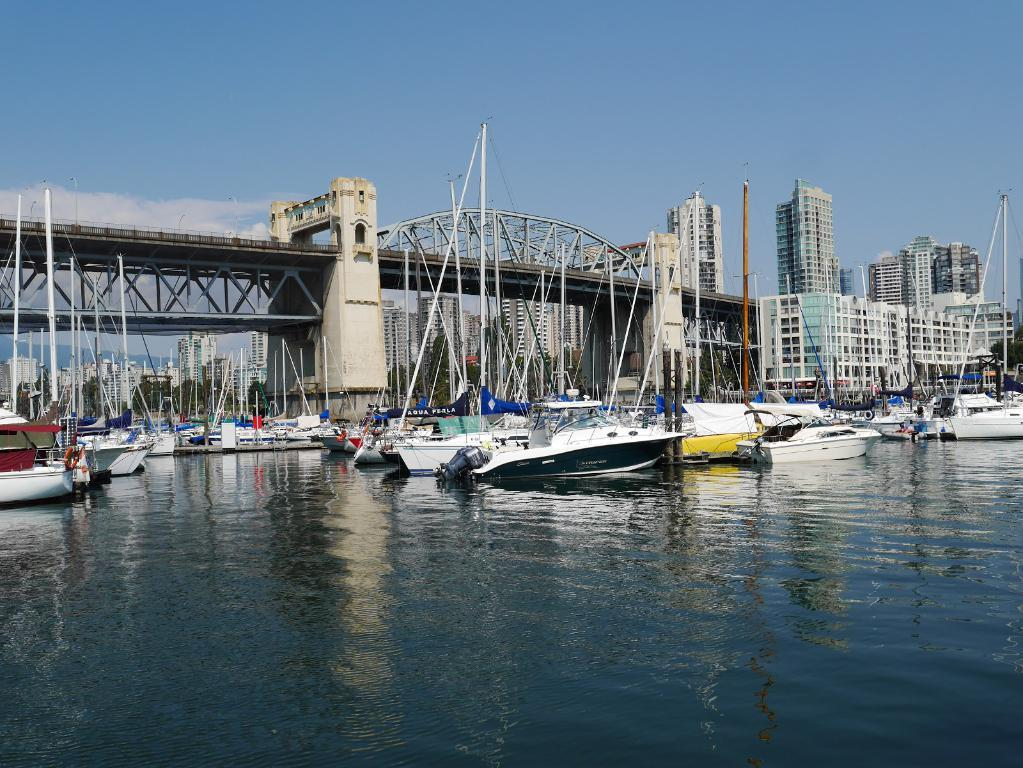What is the main feature of the image? There is water in the image. What can be seen floating on the water? There are boats in the water. What structure is visible in the image? There is a bridge in the image. What type of buildings are present on the right side of the image? There are large buildings on the right side of the image. Can you see a feather floating on the water in the image? No, there is no feather present in the image. How many people are lifting the boats in the image? There are no people lifting the boats in the image; the boats are floating on the water. 